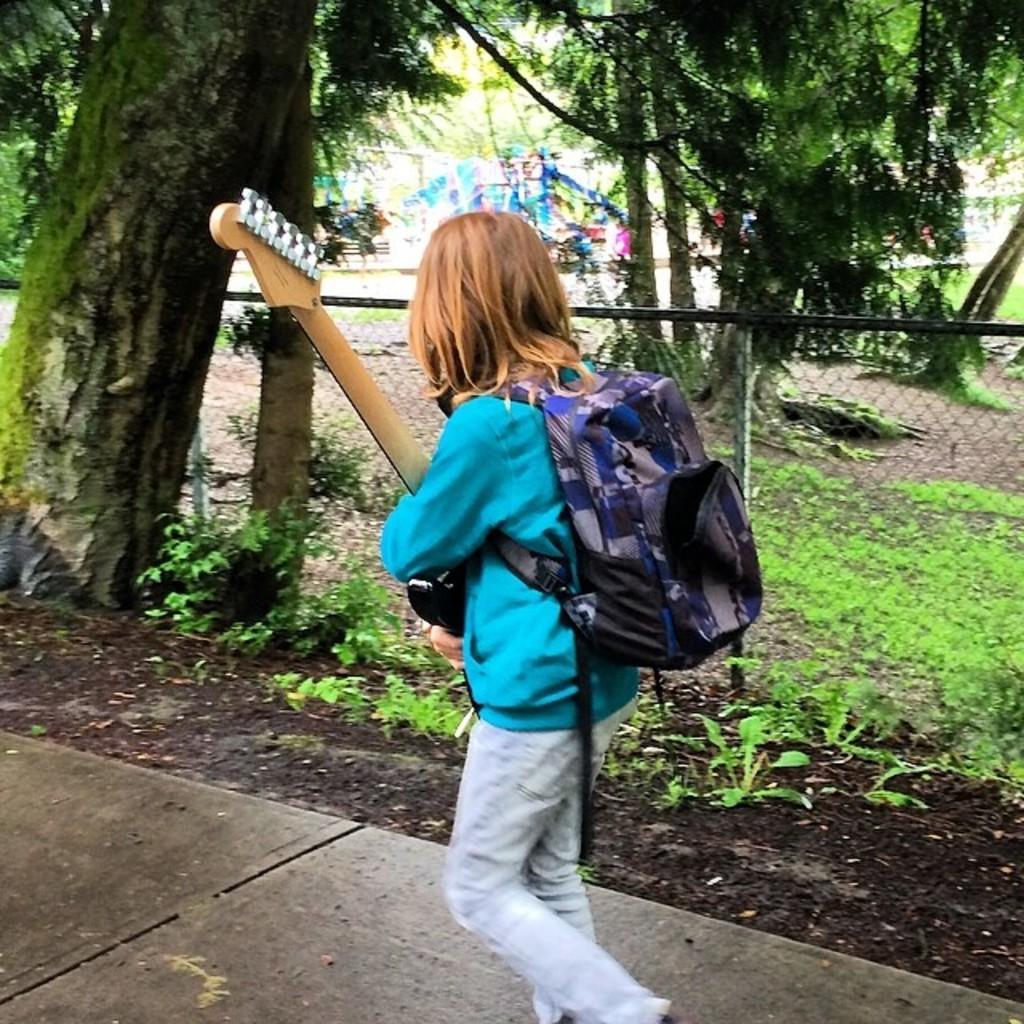In one or two sentences, can you explain what this image depicts? In this image we can see this person wearing a blue sweater and a backpack is holding a guitar in her hands and walking on the road. In the background, we can see the fence, trees, grass and children playing in the play area. 